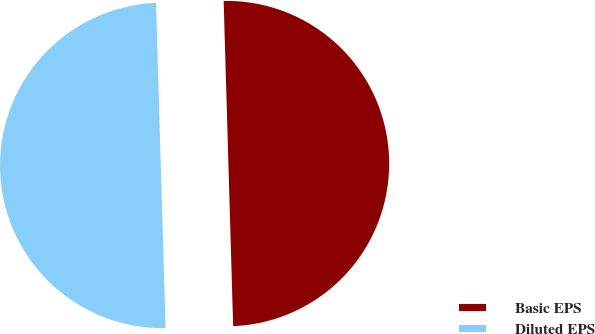Convert chart. <chart><loc_0><loc_0><loc_500><loc_500><pie_chart><fcel>Basic EPS<fcel>Diluted EPS<nl><fcel>50.0%<fcel>50.0%<nl></chart> 